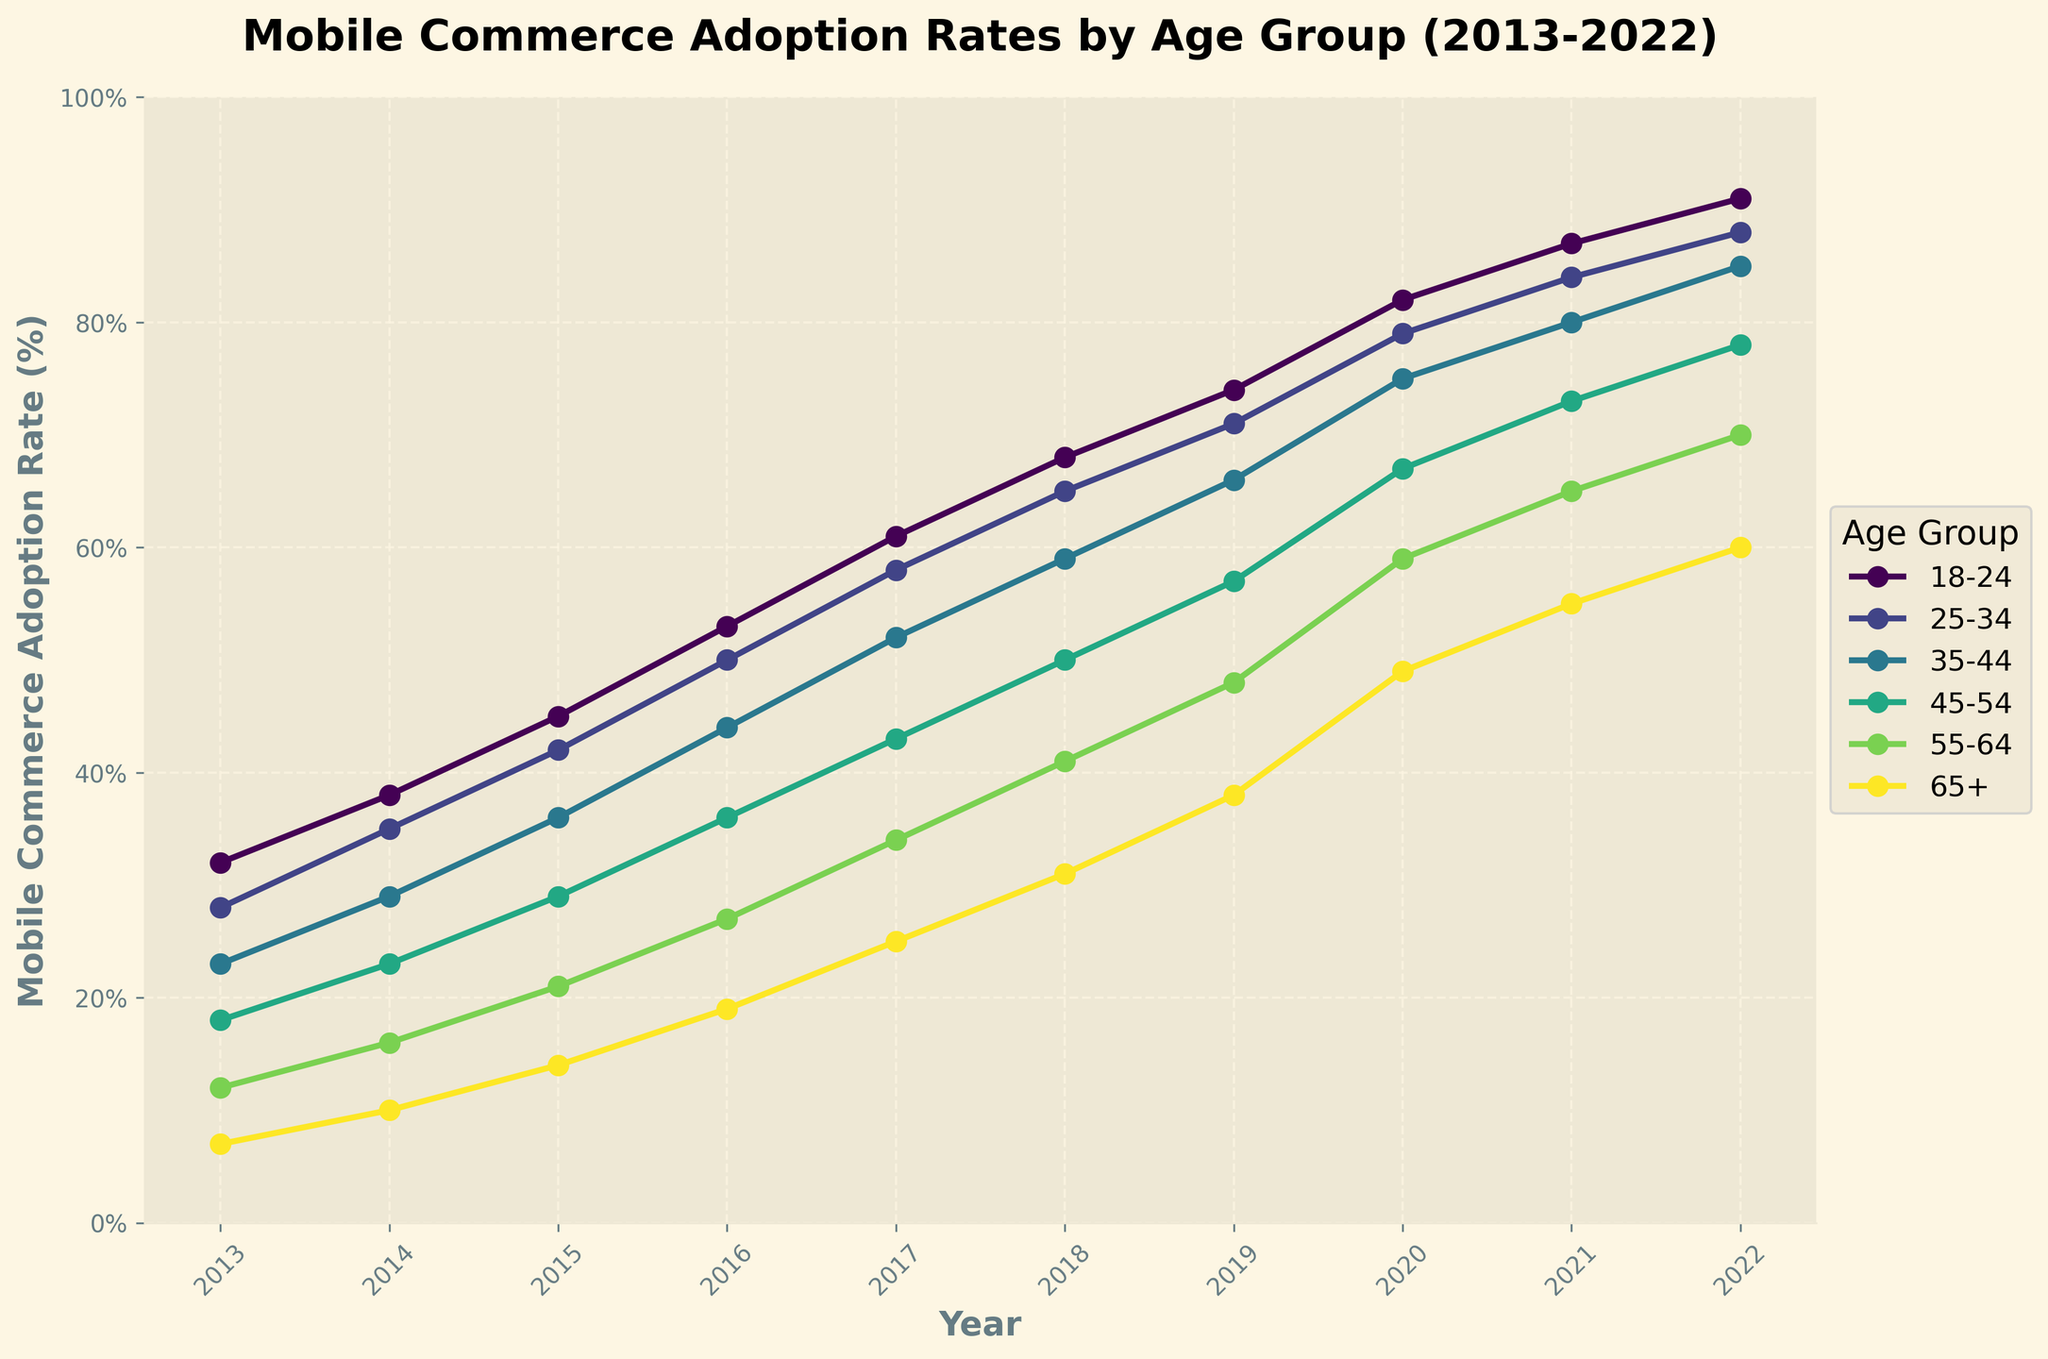What is the adoption rate of the 25-34 age group in 2020? To find this rate, locate the 25-34 age group in the legend, follow its color-coded line to the year 2020 on the x-axis, and identify the corresponding y-axis value. Here it intersects at 79%.
Answer: 79% Which age group saw the highest increase in adoption rate from 2013 to 2022? Calculate the difference in adoption rates between 2022 and 2013 for each age group. The 18-24 age group increased from 32% to 91%, a rise of 59%, which is the largest increase.
Answer: 18-24 How do the 35-44 and 45-54 age groups compare in 2018? Locate the adoption rates for both age groups in 2018. The 35-44 age group has a rate of 59%, and the 45-54 age group has a rate of 50%.
Answer: The 35-44 age group is higher What is the average adoption rate for the 65+ age group over the decade? Sum the adoption rates for the 65+ age group from 2013 to 2022 and divide by the number of years. (7% + 10% + 14% + 19% + 25% + 31% + 38% + 49% + 55% + 60%) / 10 = 30.80%
Answer: 30.80% Which year did the 18-24 age group first exceed 80% adoption rate? Track the 18-24 line across the years and identify where it first surpasses the 80% mark. This occurs in 2020 with an 82% adoption rate.
Answer: 2020 Compare the adoption rates of the 55-64 and 65+ age groups in 2022. Which is higher and by how much? Find the rates for both groups in 2022: 70% for 55-64 and 60% for 65+. The 55-64 age group's adoption is 10% higher.
Answer: 55-64 age group by 10% What specific trend is observed in the adoption rates of all age groups from 2017 to 2020? Examine the lines for each age group between 2017 and 2020. All age groups show steady and significant increases in adoption rates over these years.
Answer: Steady increase Which age group had the smallest growth in mobile commerce adoption rate from 2019 to 2022? Calculate the difference in rates for each age group between 2019 and 2022. The 65+ age group grew from 38% to 60%, an increase of 22%, which is the smallest.
Answer: 65+ In 2015, which age group had an adoption rate closest to 30%? Look at the 2015 data points for each age group. The 45-54 age group had an adoption rate of 29%, which is closest to 30%.
Answer: 45-54 What is the trend difference between the 18-24 and 55-64 age groups from 2013 to 2022? Observe the slope of the two lines. The 18-24 age group rises sharply from 32% to 91%, while the 55-64 group increases more gradually from 12% to 70%.
Answer: The 18-24 group increased more sharply 